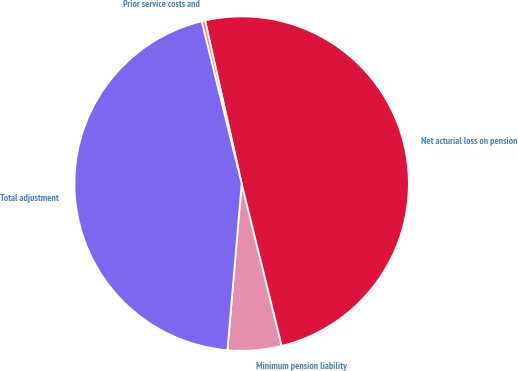<chart> <loc_0><loc_0><loc_500><loc_500><pie_chart><fcel>Minimum pension liability<fcel>Net acturial loss on pension<fcel>Prior service costs and<fcel>Total adjustment<nl><fcel>5.21%<fcel>49.66%<fcel>0.34%<fcel>44.79%<nl></chart> 